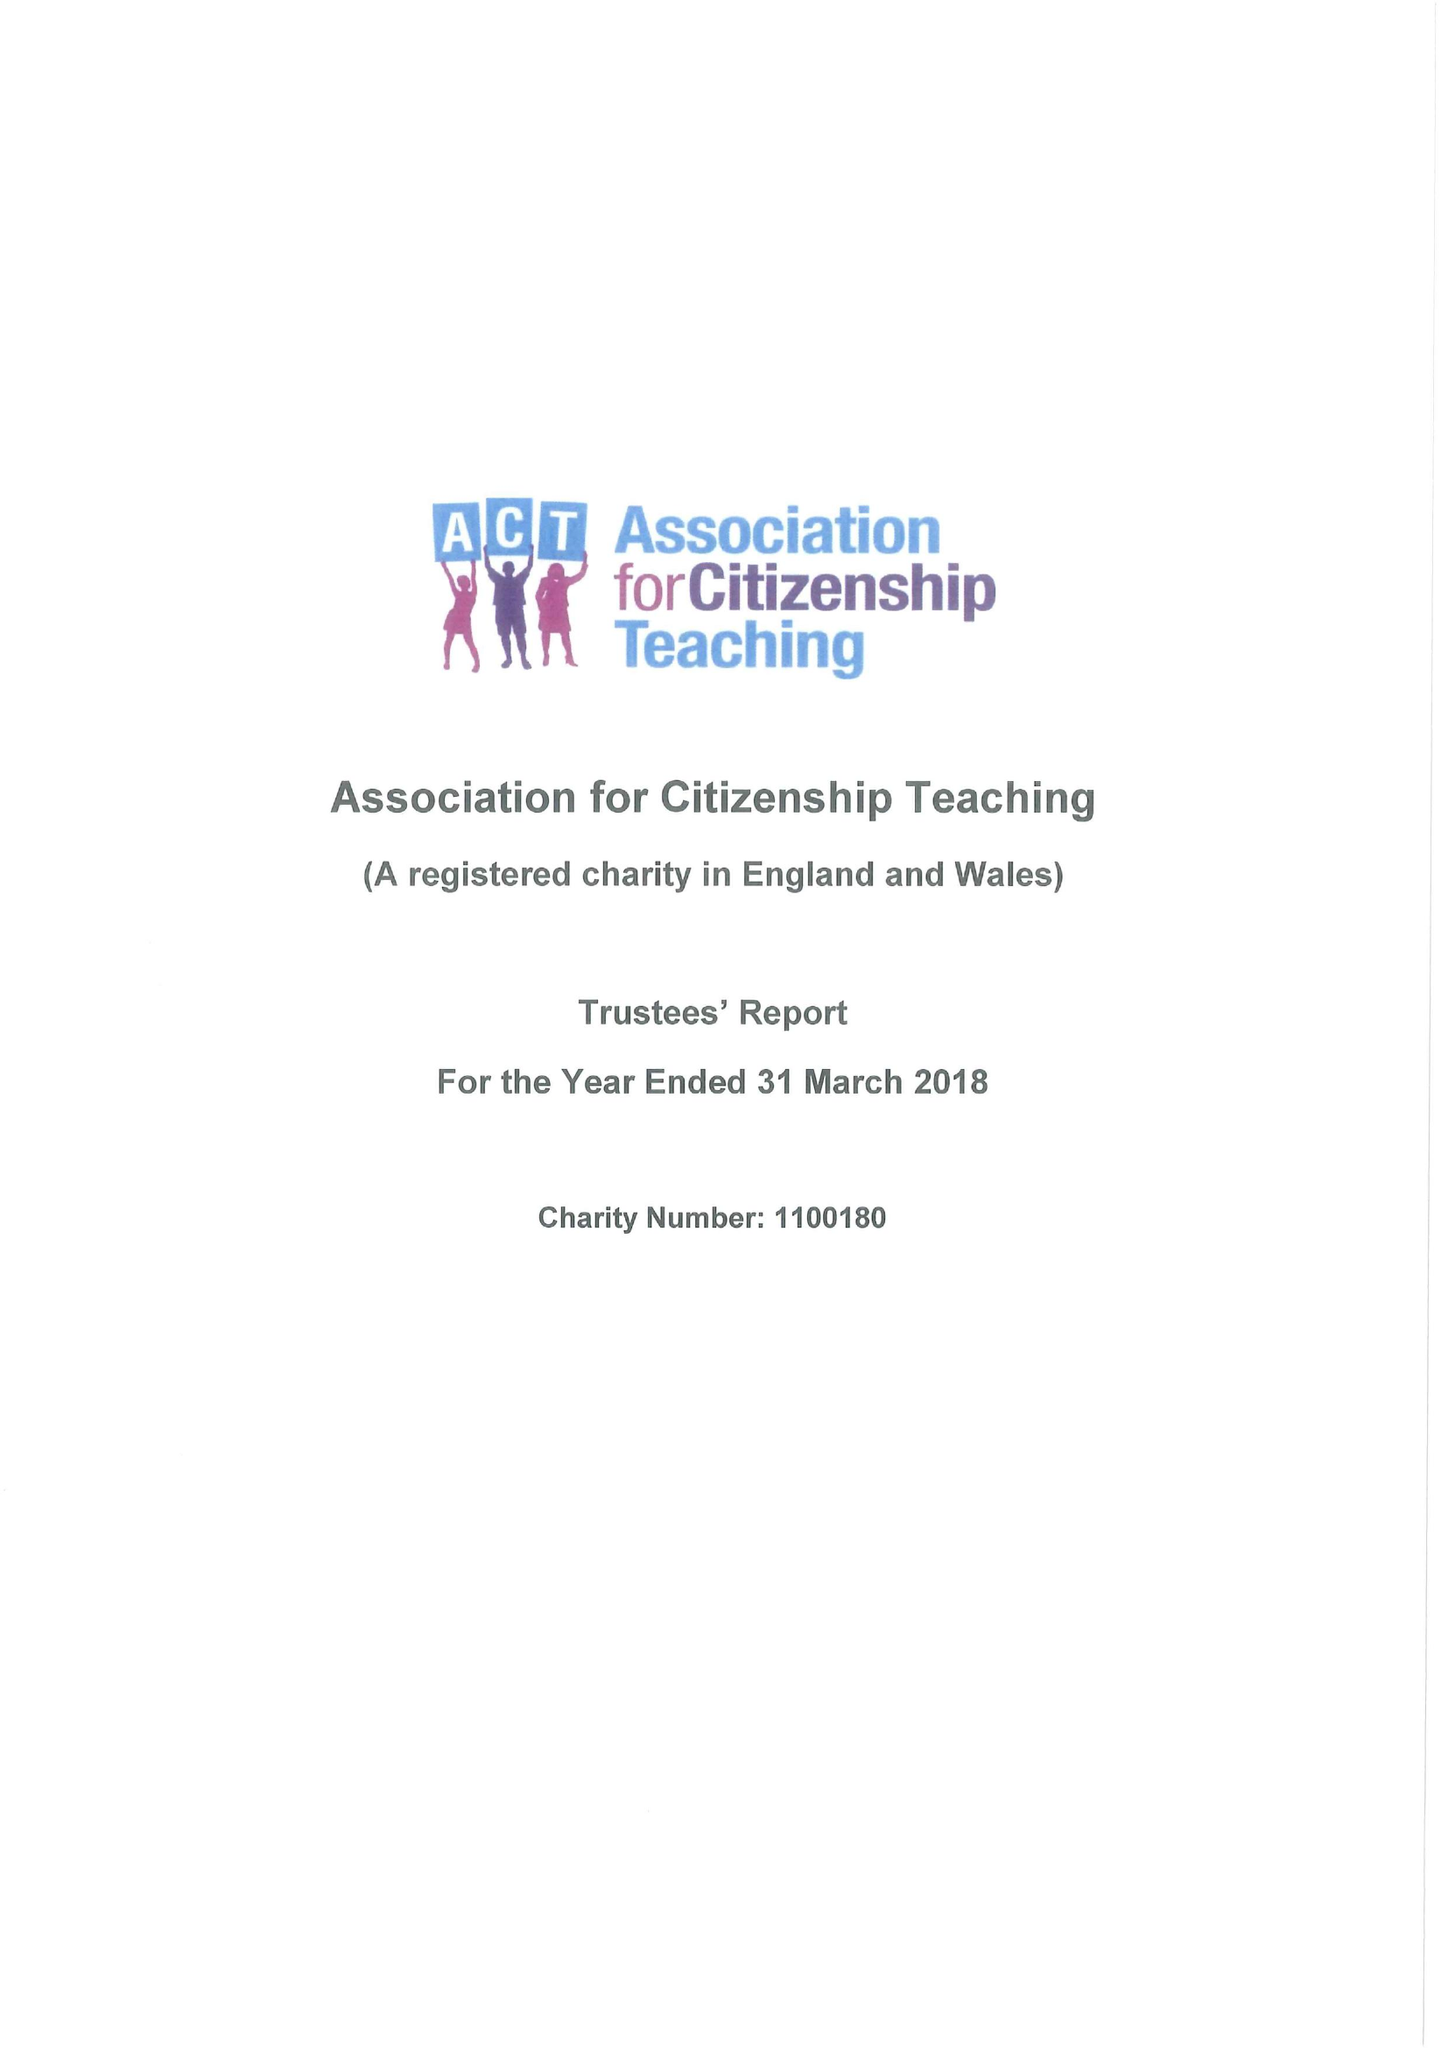What is the value for the income_annually_in_british_pounds?
Answer the question using a single word or phrase. 160996.00 